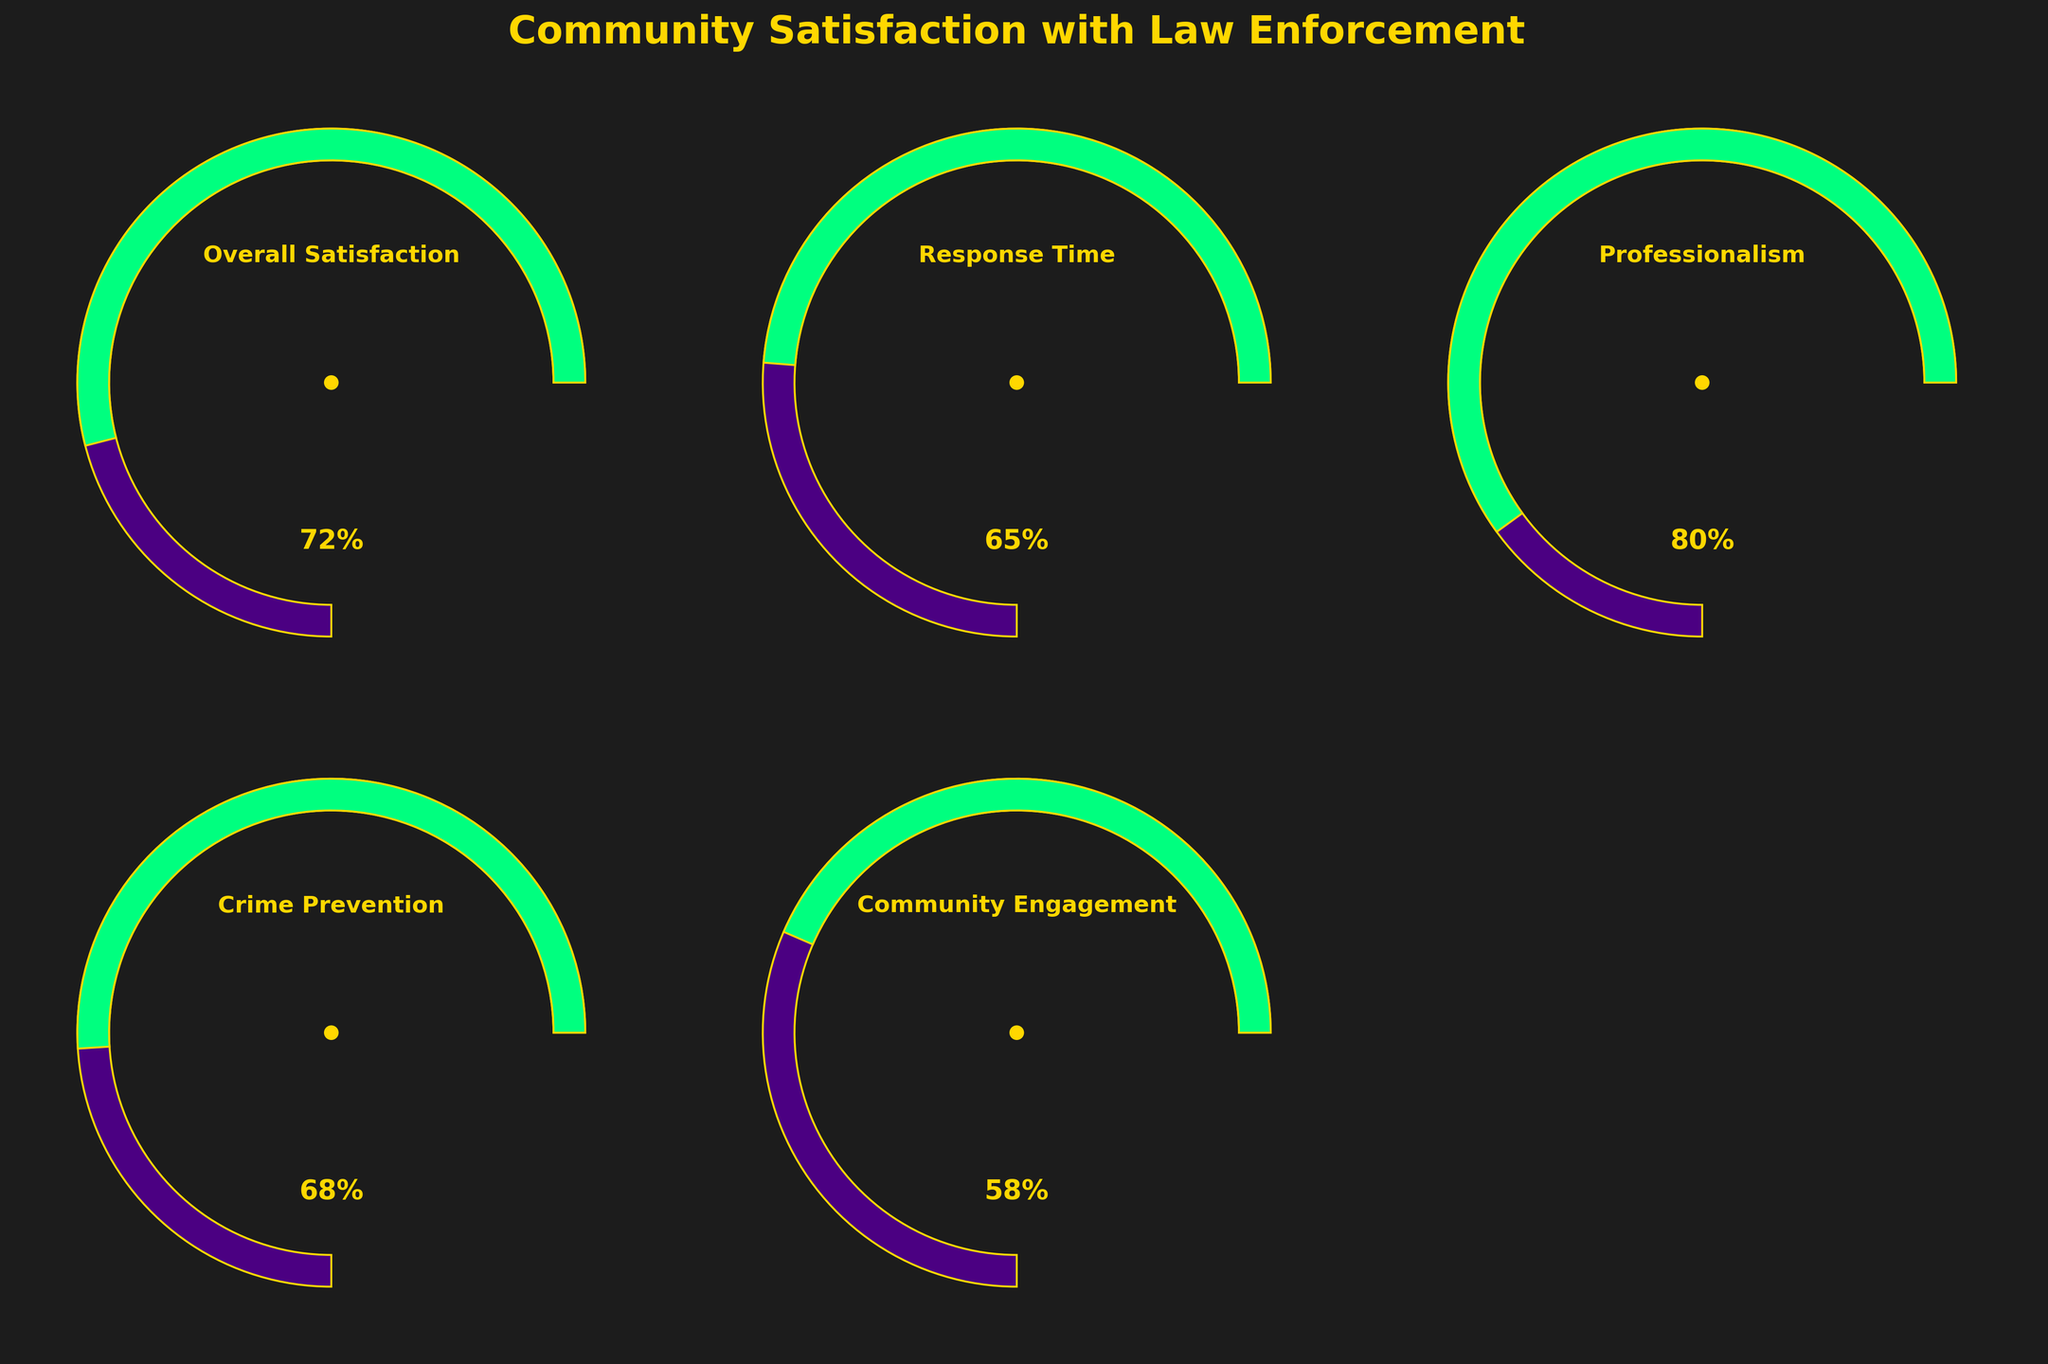What's the percentage value of Overall Satisfaction? The figure shows the data for Overall Satisfaction in one of its gauge plots. The needle points to the value given on the circle, which is 72%.
Answer: 72% Which category has the highest satisfaction level? To determine the highest satisfaction level, compare the needle positions across all gauge charts. The category with the needle pointing to the highest percentage is Professionalism, which is 80%.
Answer: Professionalism What's the difference in satisfaction levels between Crime Prevention and Community Engagement? The satisfaction level for Crime Prevention is 68%, and for Community Engagement, it's 58%. The difference is 68 - 58 = 10%.
Answer: 10% What is the title of the entire figure? The title is printed at the top of the figure as "Community Satisfaction with Law Enforcement."
Answer: Community Satisfaction with Law Enforcement What's the average satisfaction level across all categories? The satisfaction levels are: Overall Satisfaction (72%), Response Time (65%), Professionalism (80%), Crime Prevention (68%), Community Engagement (58%). The average is calculated as (72 + 65 + 80 + 68 + 58) / 5 = 68.6%.
Answer: 68.6% How many gauge charts are completely displayed in the figure? Count the number of visible gauge charts in the figure. There are five gauges for each category.
Answer: 5 Which category has a satisfaction level closest to 70%? By checking each gauge's needle, both Overall Satisfaction (72%) and Crime Prevention (68%) are close. Determine which is closest: 72 - 70 = 2, and 70 - 68 = 2; thus, both are equally close.
Answer: Overall Satisfaction and Crime Prevention What colors are used for the needle indicator and the circle’s border? The color of the gauge indicators and circle’s borders is visible in the figure, predominantly shown as gold.
Answer: Gold What's the median satisfaction level among all categories? To find the median value, first list the satisfaction levels: 72, 65, 80, 68, 58. Arrange them in ascending order: 58, 65, 68, 72, 80. The median value is the middle one: 68%.
Answer: 68% Is there any gauge chart with a satisfaction level below 60%? Check each gauge's needle position, Community Engagement has a satisfaction level of 58%, which is below 60%.
Answer: Yes 